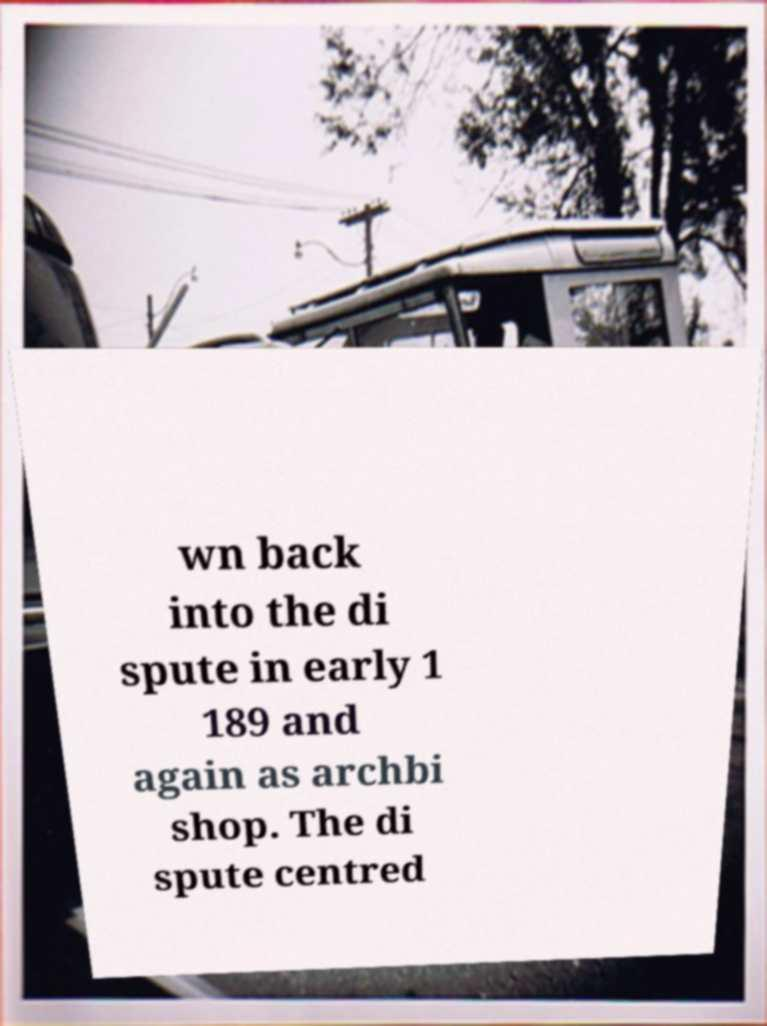For documentation purposes, I need the text within this image transcribed. Could you provide that? wn back into the di spute in early 1 189 and again as archbi shop. The di spute centred 